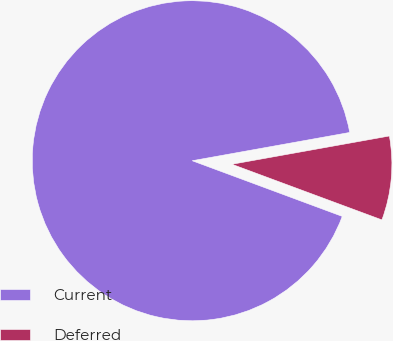Convert chart. <chart><loc_0><loc_0><loc_500><loc_500><pie_chart><fcel>Current<fcel>Deferred<nl><fcel>91.52%<fcel>8.48%<nl></chart> 